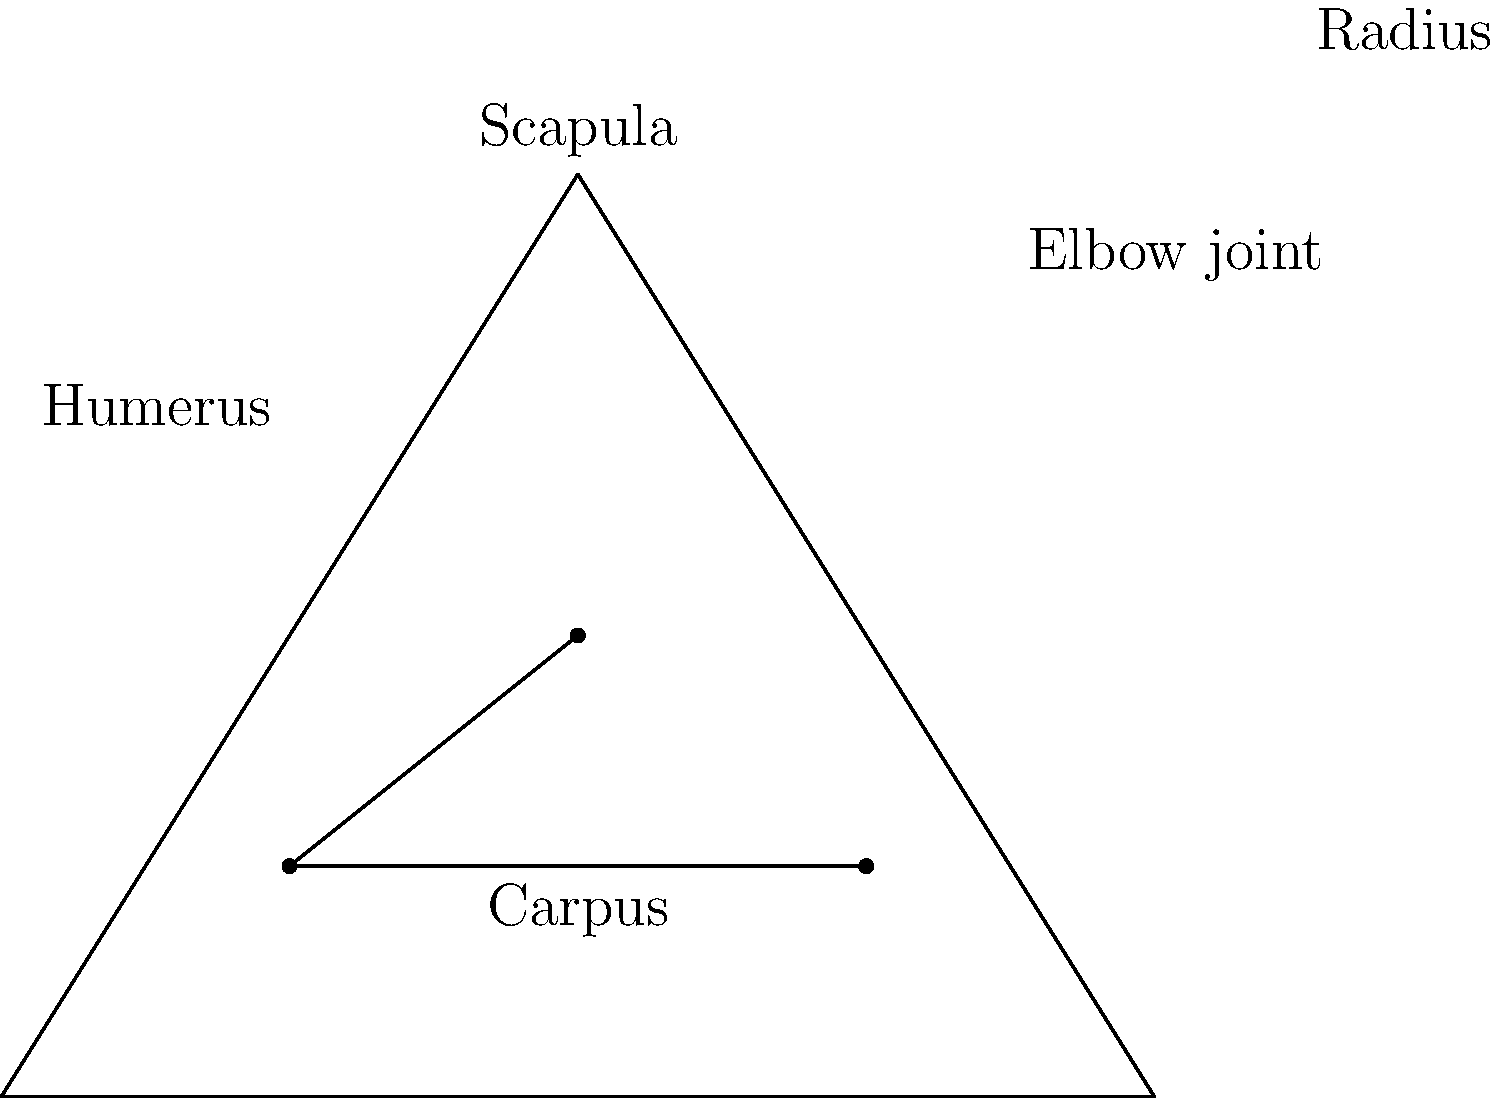Identify the bone that connects the scapula to the elbow joint in a horse's foreleg, and explain its role in the horse's movement. To answer this question, let's break down the anatomy of a horse's foreleg:

1. The scapula (shoulder blade) is the flat, triangular bone at the top of the foreleg.
2. The elbow joint is the articulation point between the upper and lower parts of the foreleg.
3. The bone connecting these two points is the humerus.
4. The humerus is a long bone that extends from the shoulder to the elbow.
5. Its role in the horse's movement includes:
   a. Providing attachment points for major muscles that control foreleg movement.
   b. Transferring force from the shoulder to the lower leg during locomotion.
   c. Allowing for a wide range of motion in the foreleg, essential for various gaits.
   d. Acting as a shock absorber during impact with the ground.
6. The humerus works in conjunction with the scapula to create the shoulder joint, which is crucial for the horse's stride length and overall movement.

Understanding the humerus and its function is essential for equestrians and trainers, as it plays a vital role in a horse's performance, gait quality, and potential lameness issues.
Answer: Humerus 